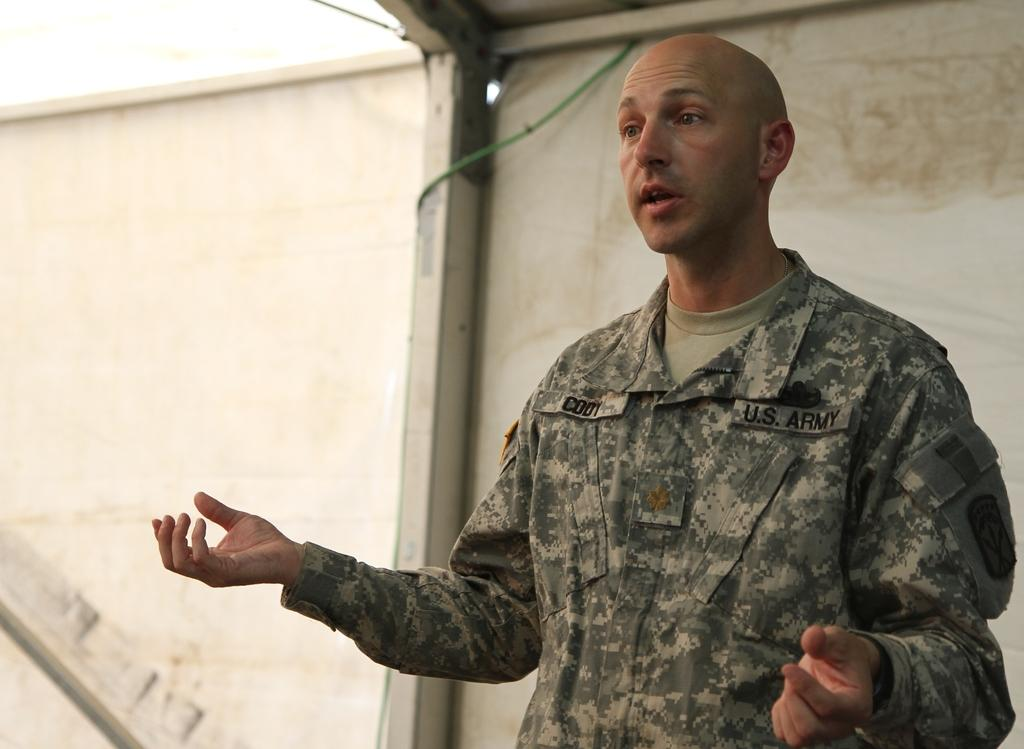Who or what is present in the image? There is a person in the image. What is the person wearing? The person is wearing a camouflage dress. What is the person's posture in the image? The person is standing. What can be seen in the background of the image? There is a white color sheet in the background of the image. Can you see a duck sitting on the chair in the image? There is no duck or chair present in the image. 